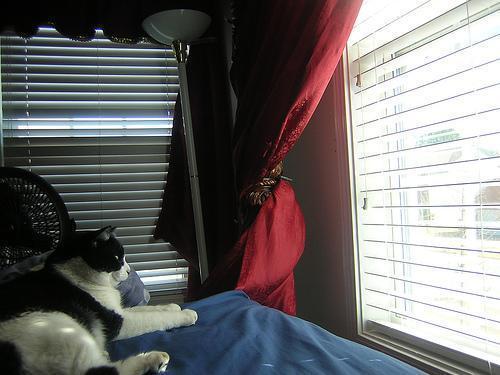How many cats are in this picture?
Give a very brief answer. 1. How many windows are in this picture?
Give a very brief answer. 2. 